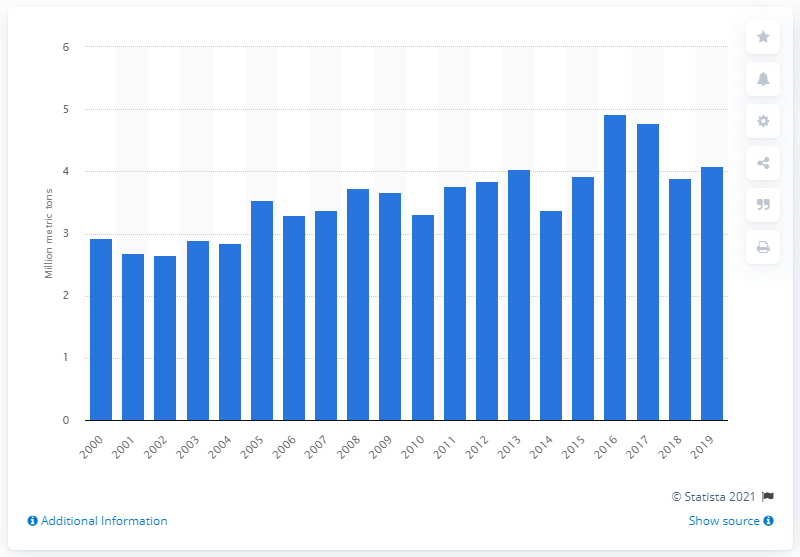Draw attention to some important aspects in this diagram. The global apricot production increased from 2000 to 2019, with a total production of 4.08 million metric tons. 